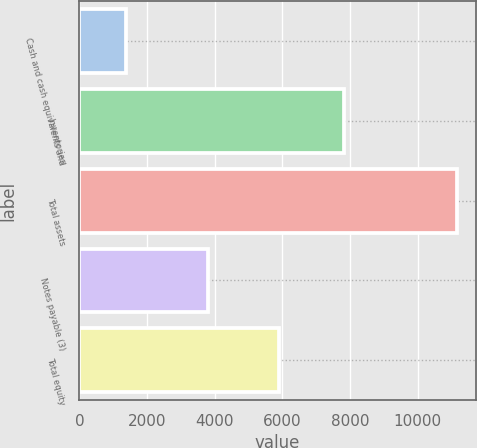Convert chart to OTSL. <chart><loc_0><loc_0><loc_500><loc_500><bar_chart><fcel>Cash and cash equivalents and<fcel>Inventories<fcel>Total assets<fcel>Notes payable (3)<fcel>Total equity<nl><fcel>1383.8<fcel>7807<fcel>11151<fcel>3811.5<fcel>5895.4<nl></chart> 